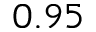Convert formula to latex. <formula><loc_0><loc_0><loc_500><loc_500>0 . 9 5</formula> 